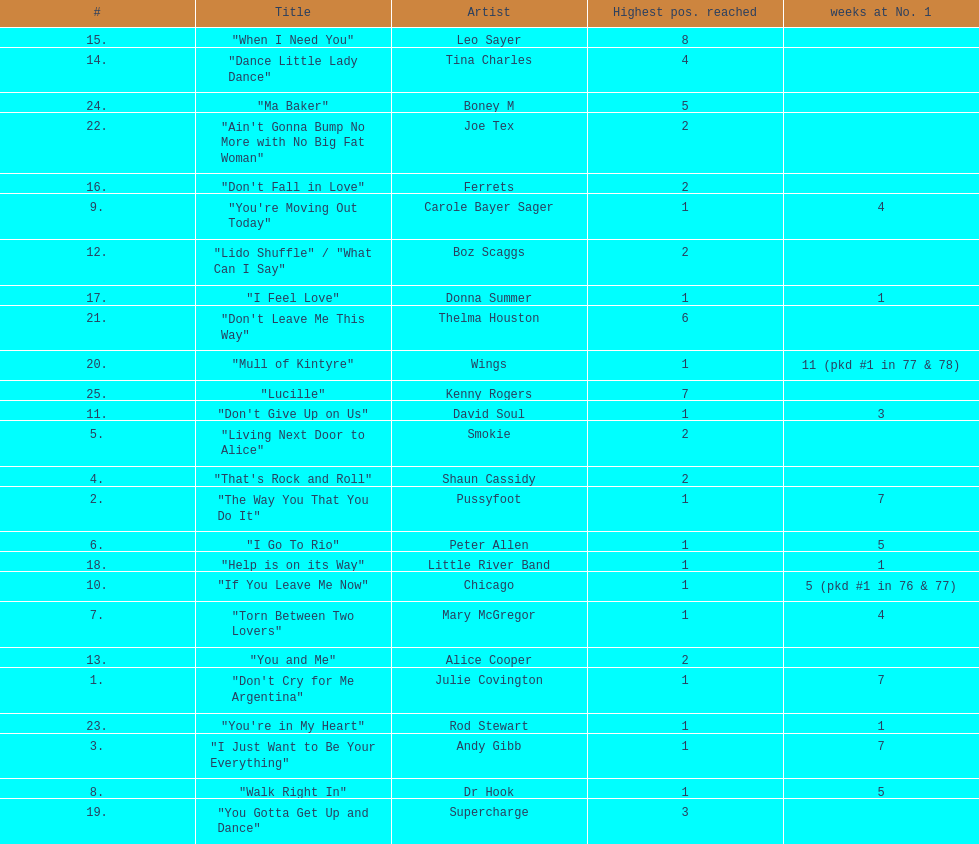Which three artists had a single at number 1 for at least 7 weeks on the australian singles charts in 1977? Julie Covington, Pussyfoot, Andy Gibb. 